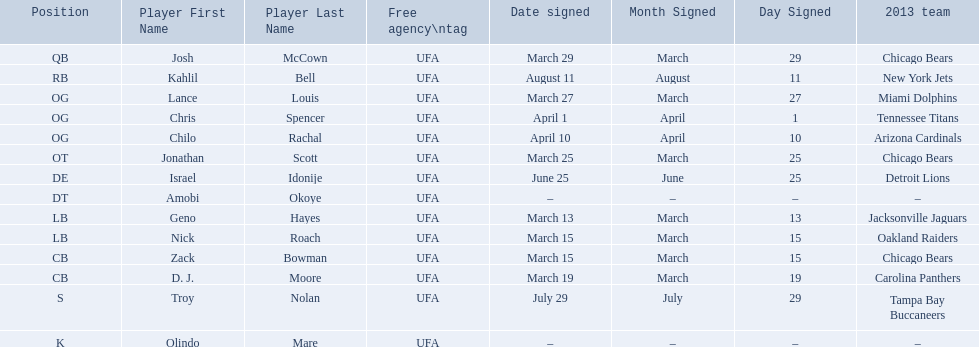Parse the table in full. {'header': ['Position', 'Player First Name', 'Player Last Name', 'Free agency\\ntag', 'Date signed', 'Month Signed', 'Day Signed', '2013 team'], 'rows': [['QB', 'Josh', 'McCown', 'UFA', 'March 29', 'March', '29', 'Chicago Bears'], ['RB', 'Kahlil', 'Bell', 'UFA', 'August 11', 'August', '11', 'New York Jets'], ['OG', 'Lance', 'Louis', 'UFA', 'March 27', 'March', '27', 'Miami Dolphins'], ['OG', 'Chris', 'Spencer', 'UFA', 'April 1', 'April', '1', 'Tennessee Titans'], ['OG', 'Chilo', 'Rachal', 'UFA', 'April 10', 'April', '10', 'Arizona Cardinals'], ['OT', 'Jonathan', 'Scott', 'UFA', 'March 25', 'March', '25', 'Chicago Bears'], ['DE', 'Israel', 'Idonije', 'UFA', 'June 25', 'June', '25', 'Detroit Lions'], ['DT', 'Amobi', 'Okoye', 'UFA', '–', '–', '–', '–'], ['LB', 'Geno', 'Hayes', 'UFA', 'March 13', 'March', '13', 'Jacksonville Jaguars'], ['LB', 'Nick', 'Roach', 'UFA', 'March 15', 'March', '15', 'Oakland Raiders'], ['CB', 'Zack', 'Bowman', 'UFA', 'March 15', 'March', '15', 'Chicago Bears'], ['CB', 'D. J.', 'Moore', 'UFA', 'March 19', 'March', '19', 'Carolina Panthers'], ['S', 'Troy', 'Nolan', 'UFA', 'July 29', 'July', '29', 'Tampa Bay Buccaneers'], ['K', 'Olindo', 'Mare', 'UFA', '–', '–', '–', '–']]} Who are all of the players? Josh McCown, Kahlil Bell, Lance Louis, Chris Spencer, Chilo Rachal, Jonathan Scott, Israel Idonije, Amobi Okoye, Geno Hayes, Nick Roach, Zack Bowman, D. J. Moore, Troy Nolan, Olindo Mare. When were they signed? March 29, August 11, March 27, April 1, April 10, March 25, June 25, –, March 13, March 15, March 15, March 19, July 29, –. Along with nick roach, who else was signed on march 15? Zack Bowman. 